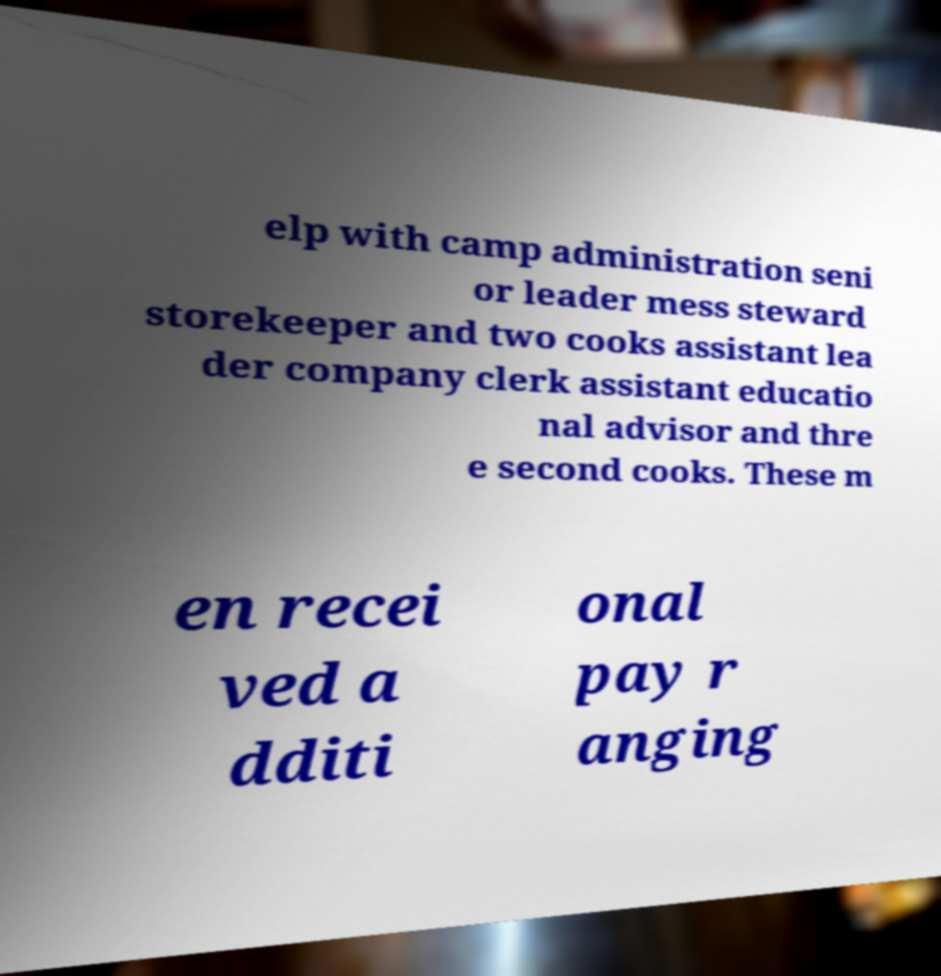There's text embedded in this image that I need extracted. Can you transcribe it verbatim? elp with camp administration seni or leader mess steward storekeeper and two cooks assistant lea der company clerk assistant educatio nal advisor and thre e second cooks. These m en recei ved a dditi onal pay r anging 